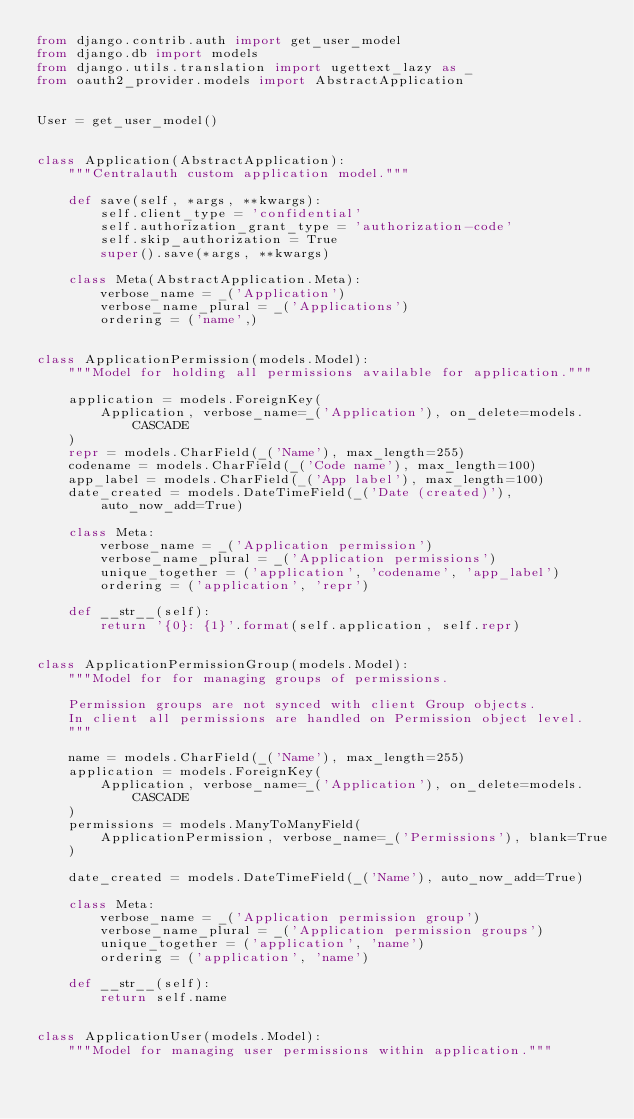<code> <loc_0><loc_0><loc_500><loc_500><_Python_>from django.contrib.auth import get_user_model
from django.db import models
from django.utils.translation import ugettext_lazy as _
from oauth2_provider.models import AbstractApplication


User = get_user_model()


class Application(AbstractApplication):
    """Centralauth custom application model."""

    def save(self, *args, **kwargs):
        self.client_type = 'confidential'
        self.authorization_grant_type = 'authorization-code'
        self.skip_authorization = True
        super().save(*args, **kwargs)

    class Meta(AbstractApplication.Meta):
        verbose_name = _('Application')
        verbose_name_plural = _('Applications')
        ordering = ('name',)


class ApplicationPermission(models.Model):
    """Model for holding all permissions available for application."""

    application = models.ForeignKey(
        Application, verbose_name=_('Application'), on_delete=models.CASCADE
    )
    repr = models.CharField(_('Name'), max_length=255)
    codename = models.CharField(_('Code name'), max_length=100)
    app_label = models.CharField(_('App label'), max_length=100)
    date_created = models.DateTimeField(_('Date (created)'), auto_now_add=True)

    class Meta:
        verbose_name = _('Application permission')
        verbose_name_plural = _('Application permissions')
        unique_together = ('application', 'codename', 'app_label')
        ordering = ('application', 'repr')

    def __str__(self):
        return '{0}: {1}'.format(self.application, self.repr)


class ApplicationPermissionGroup(models.Model):
    """Model for for managing groups of permissions.

    Permission groups are not synced with client Group objects.
    In client all permissions are handled on Permission object level.
    """

    name = models.CharField(_('Name'), max_length=255)
    application = models.ForeignKey(
        Application, verbose_name=_('Application'), on_delete=models.CASCADE
    )
    permissions = models.ManyToManyField(
        ApplicationPermission, verbose_name=_('Permissions'), blank=True
    )

    date_created = models.DateTimeField(_('Name'), auto_now_add=True)

    class Meta:
        verbose_name = _('Application permission group')
        verbose_name_plural = _('Application permission groups')
        unique_together = ('application', 'name')
        ordering = ('application', 'name')

    def __str__(self):
        return self.name


class ApplicationUser(models.Model):
    """Model for managing user permissions within application."""
</code> 